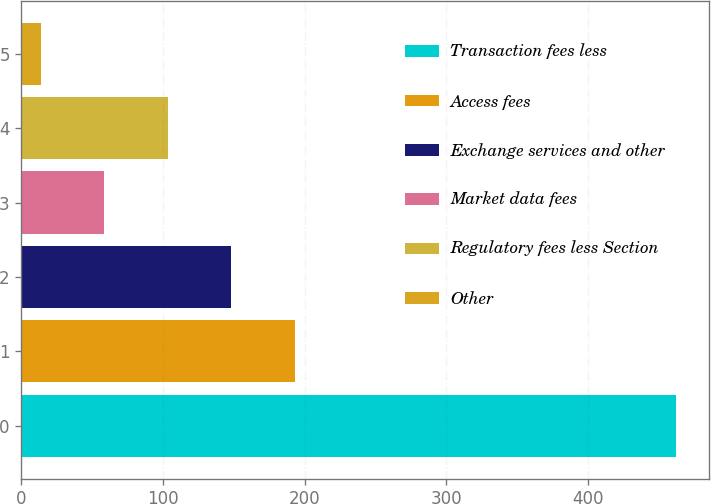<chart> <loc_0><loc_0><loc_500><loc_500><bar_chart><fcel>Transaction fees less<fcel>Access fees<fcel>Exchange services and other<fcel>Market data fees<fcel>Regulatory fees less Section<fcel>Other<nl><fcel>462.4<fcel>193.12<fcel>148.24<fcel>58.48<fcel>103.36<fcel>13.6<nl></chart> 